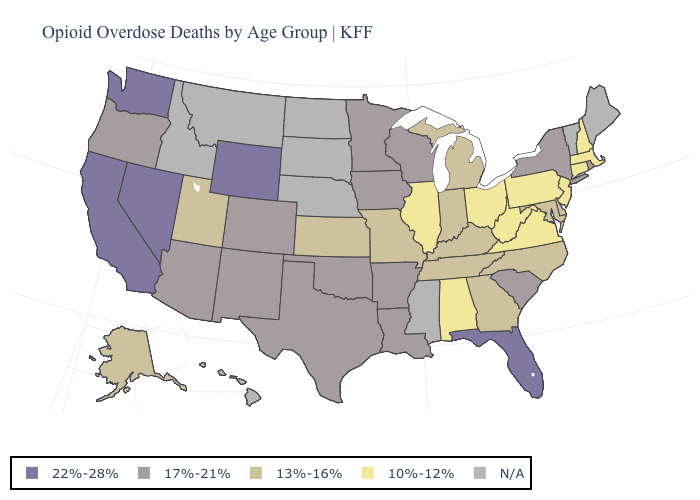What is the lowest value in the West?
Quick response, please. 13%-16%. What is the value of Virginia?
Keep it brief. 10%-12%. Name the states that have a value in the range 22%-28%?
Quick response, please. California, Florida, Nevada, Washington, Wyoming. Is the legend a continuous bar?
Keep it brief. No. Which states have the lowest value in the South?
Keep it brief. Alabama, Virginia, West Virginia. Which states have the lowest value in the South?
Answer briefly. Alabama, Virginia, West Virginia. What is the value of Illinois?
Write a very short answer. 10%-12%. Among the states that border Connecticut , does New York have the lowest value?
Keep it brief. No. Name the states that have a value in the range 13%-16%?
Short answer required. Alaska, Delaware, Georgia, Indiana, Kansas, Kentucky, Maryland, Michigan, Missouri, North Carolina, Tennessee, Utah. What is the value of Oregon?
Be succinct. 17%-21%. What is the value of North Carolina?
Give a very brief answer. 13%-16%. What is the value of Florida?
Be succinct. 22%-28%. What is the highest value in the USA?
Short answer required. 22%-28%. What is the lowest value in the West?
Concise answer only. 13%-16%. 